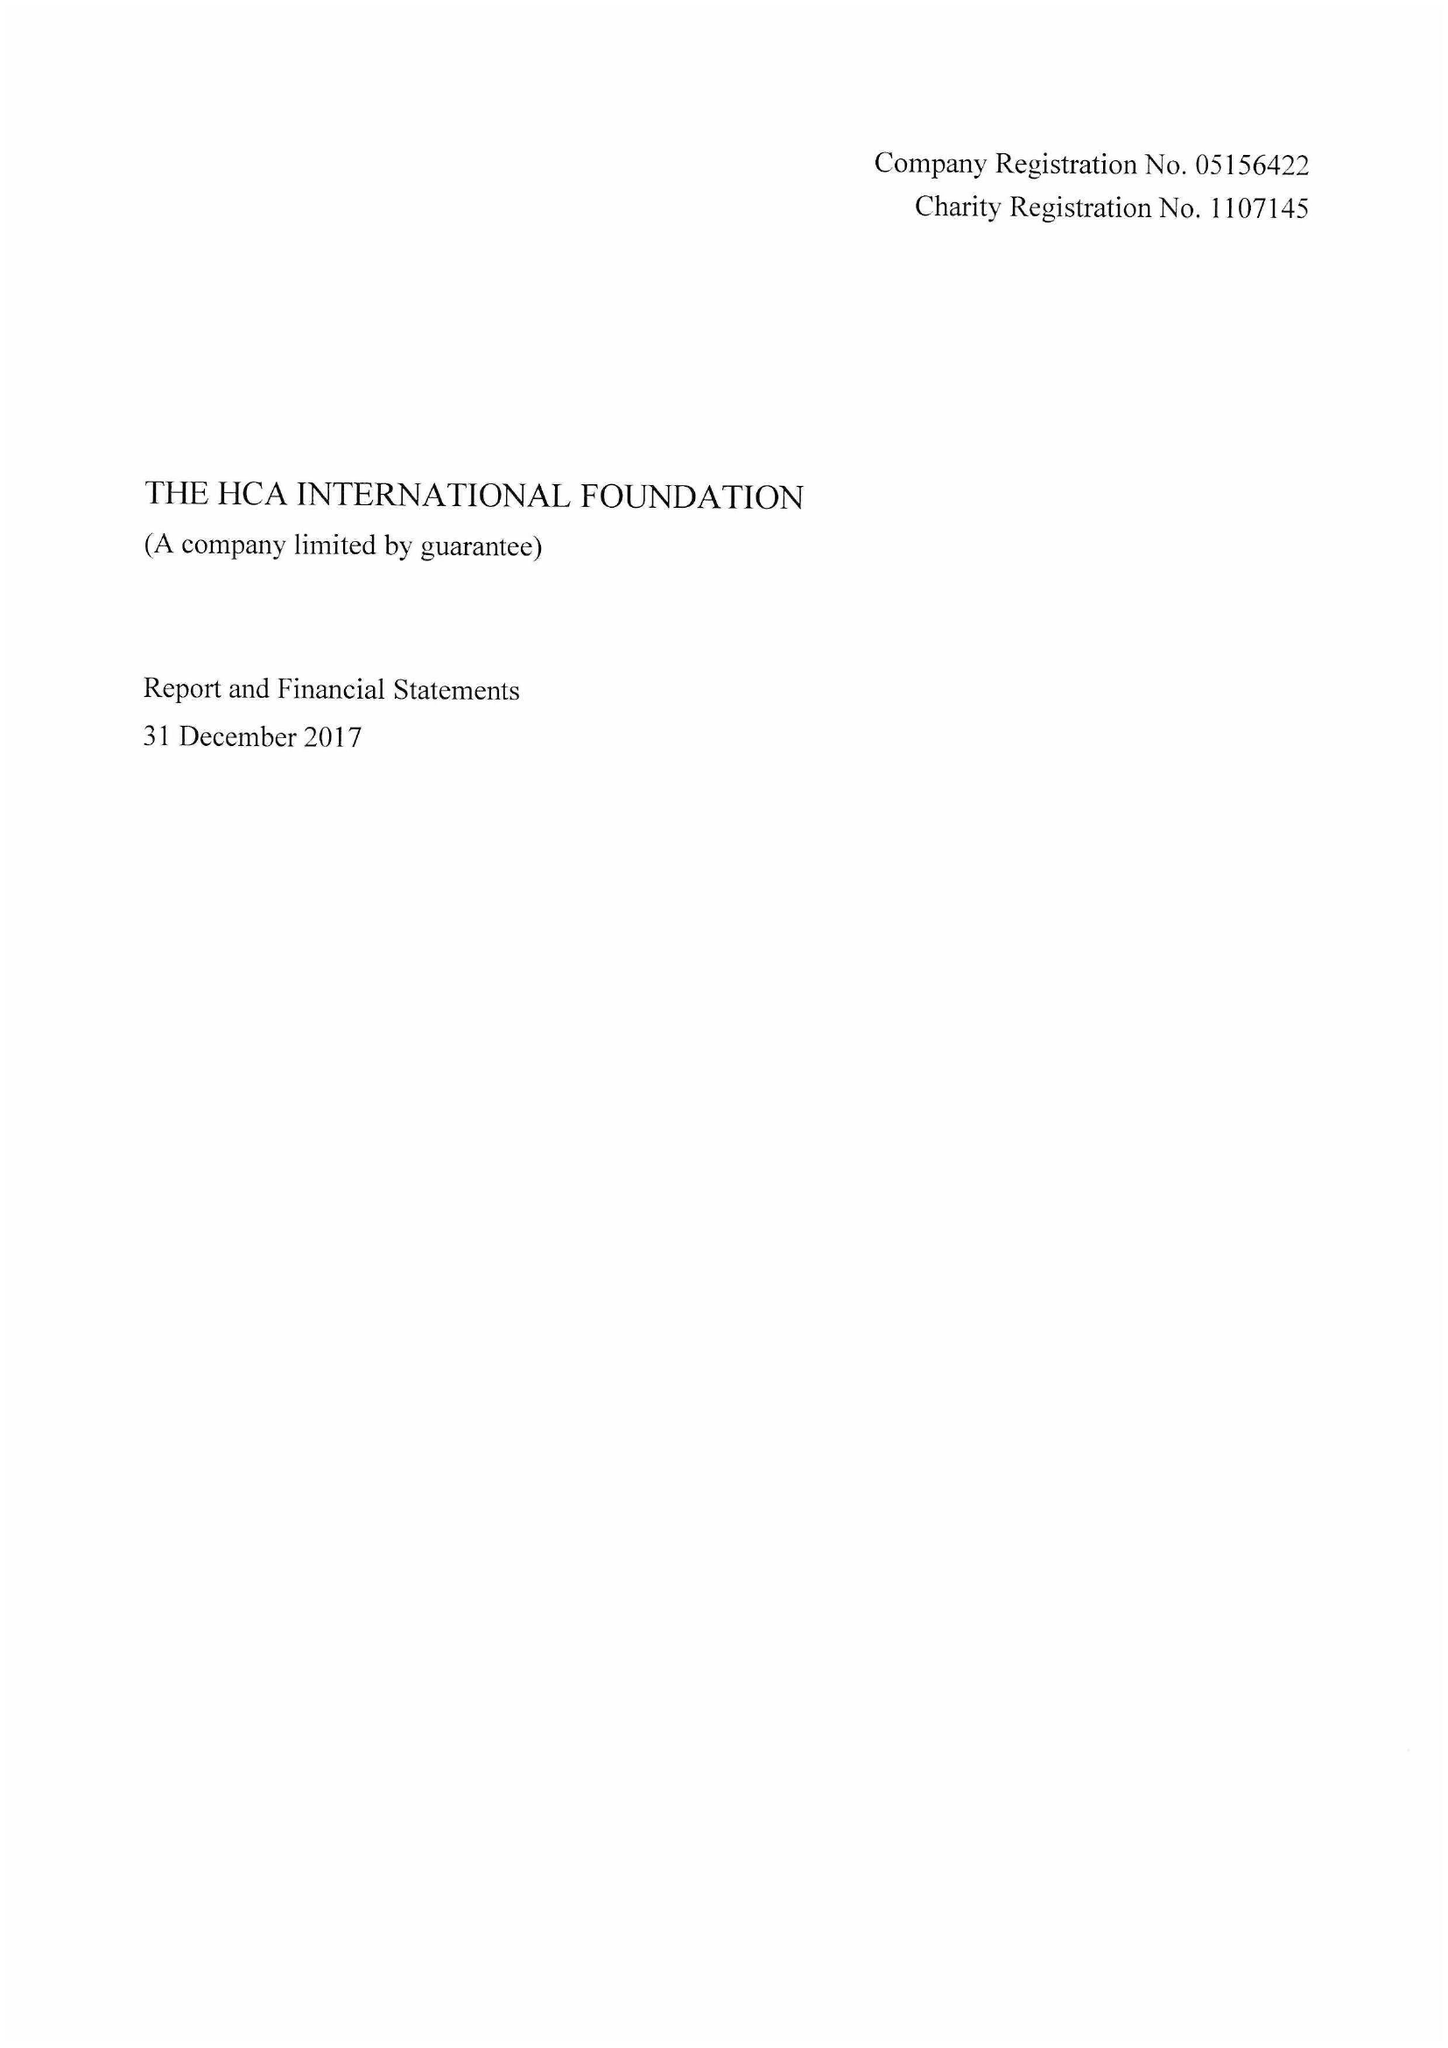What is the value for the charity_number?
Answer the question using a single word or phrase. 1107145 